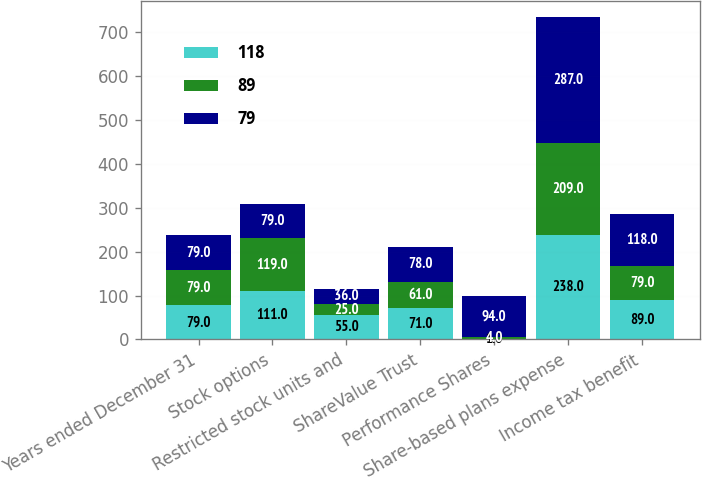Convert chart. <chart><loc_0><loc_0><loc_500><loc_500><stacked_bar_chart><ecel><fcel>Years ended December 31<fcel>Stock options<fcel>Restricted stock units and<fcel>ShareValue Trust<fcel>Performance Shares<fcel>Share-based plans expense<fcel>Income tax benefit<nl><fcel>118<fcel>79<fcel>111<fcel>55<fcel>71<fcel>1<fcel>238<fcel>89<nl><fcel>89<fcel>79<fcel>119<fcel>25<fcel>61<fcel>4<fcel>209<fcel>79<nl><fcel>79<fcel>79<fcel>79<fcel>36<fcel>78<fcel>94<fcel>287<fcel>118<nl></chart> 